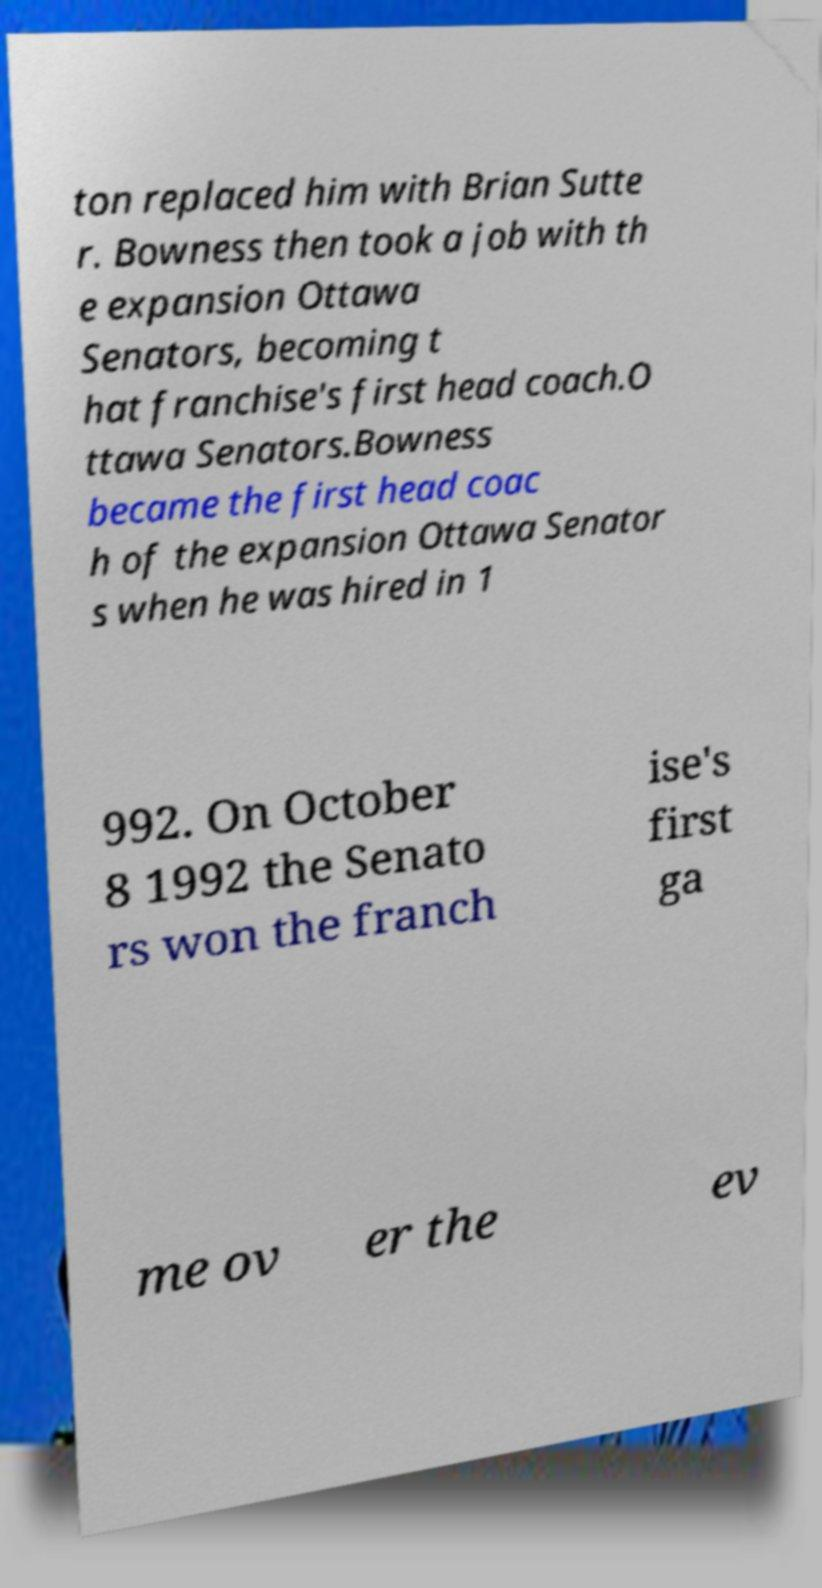Please read and relay the text visible in this image. What does it say? ton replaced him with Brian Sutte r. Bowness then took a job with th e expansion Ottawa Senators, becoming t hat franchise's first head coach.O ttawa Senators.Bowness became the first head coac h of the expansion Ottawa Senator s when he was hired in 1 992. On October 8 1992 the Senato rs won the franch ise's first ga me ov er the ev 